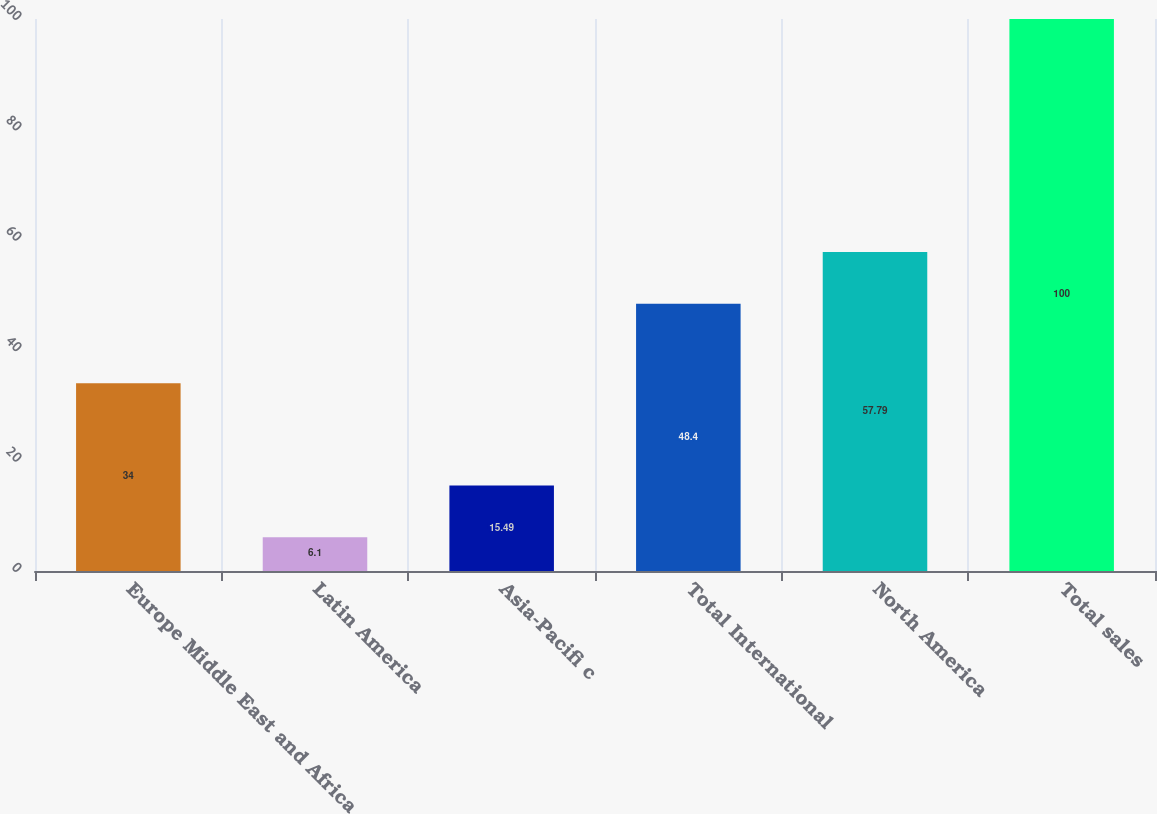Convert chart to OTSL. <chart><loc_0><loc_0><loc_500><loc_500><bar_chart><fcel>Europe Middle East and Africa<fcel>Latin America<fcel>Asia-Pacifi c<fcel>Total International<fcel>North America<fcel>Total sales<nl><fcel>34<fcel>6.1<fcel>15.49<fcel>48.4<fcel>57.79<fcel>100<nl></chart> 